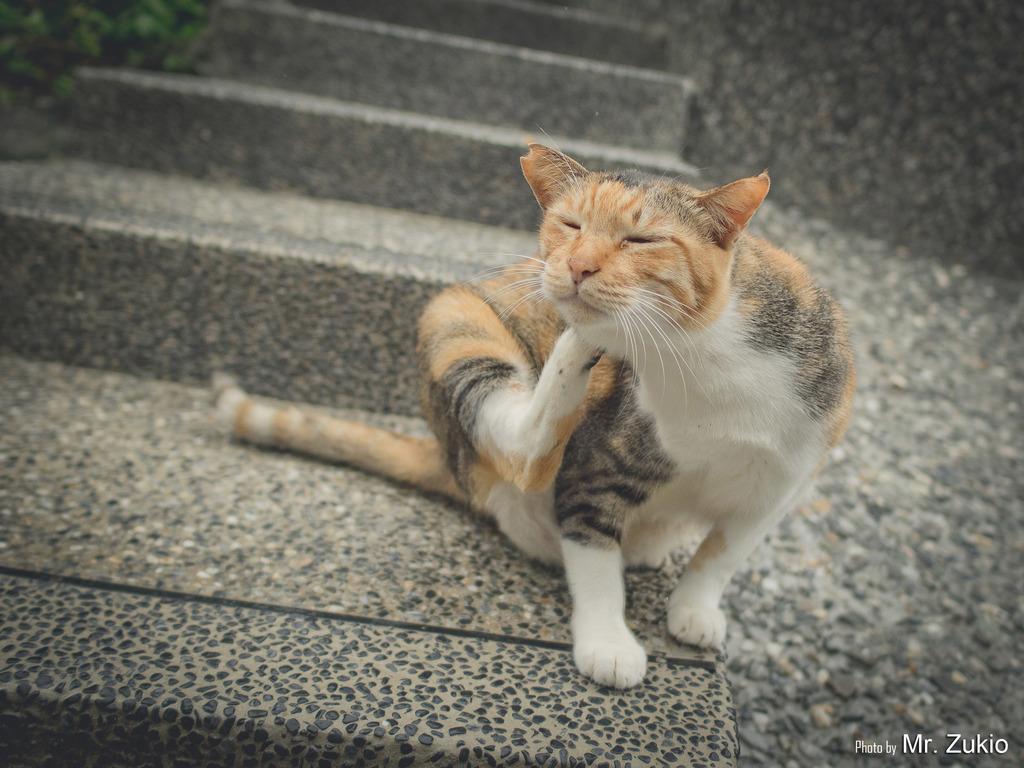Can you describe this image briefly? In this picture there is a cat sitting and itching with one of its leg and there is something written in the right bottom corner. 